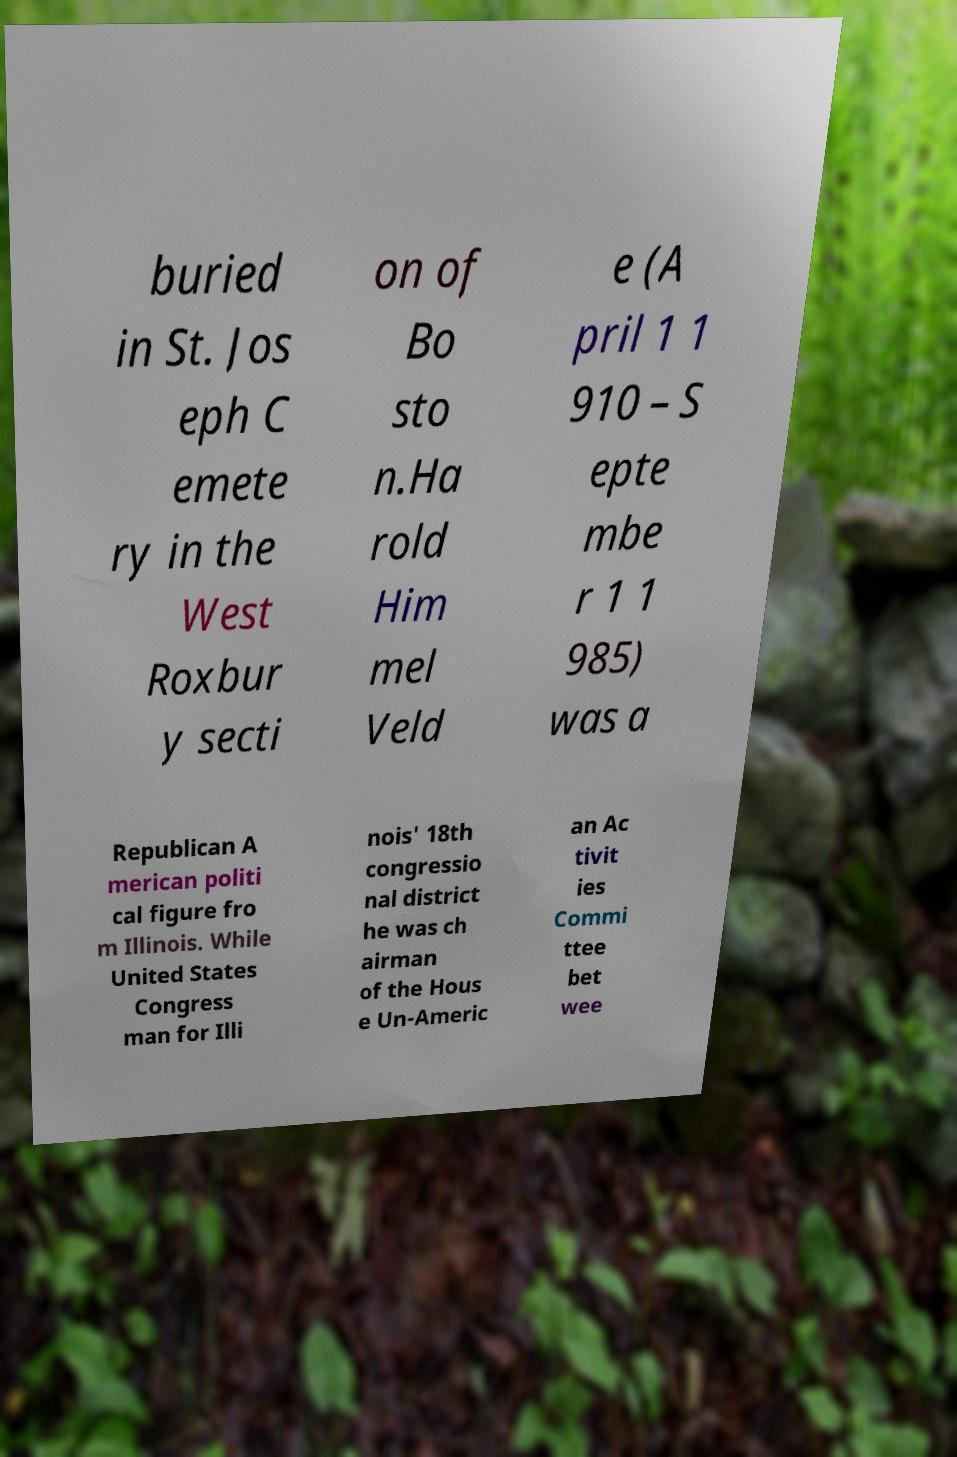Please read and relay the text visible in this image. What does it say? buried in St. Jos eph C emete ry in the West Roxbur y secti on of Bo sto n.Ha rold Him mel Veld e (A pril 1 1 910 – S epte mbe r 1 1 985) was a Republican A merican politi cal figure fro m Illinois. While United States Congress man for Illi nois' 18th congressio nal district he was ch airman of the Hous e Un-Americ an Ac tivit ies Commi ttee bet wee 